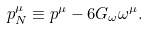Convert formula to latex. <formula><loc_0><loc_0><loc_500><loc_500>p _ { N } ^ { \mu } \equiv p ^ { \mu } - 6 G _ { \omega } \omega ^ { \mu } .</formula> 